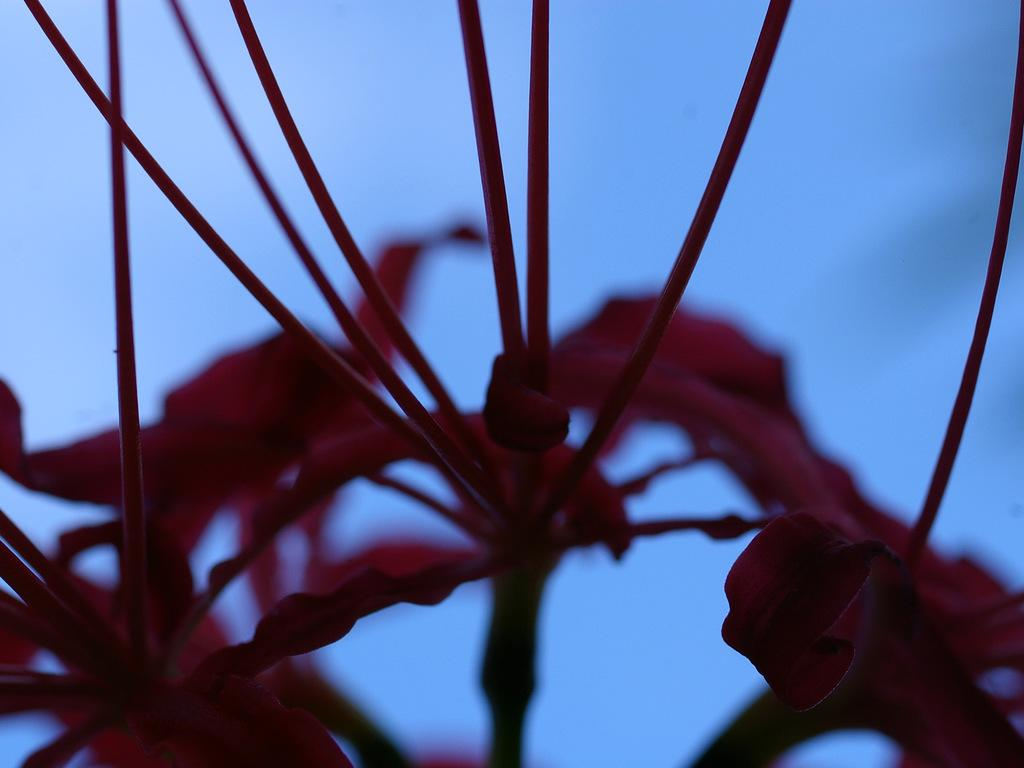What is the main subject of the image? There is a flower in the image. What can be seen in the background of the image? The sky is visible in the background of the image. What type of disease is affecting the flower in the image? There is no indication of any disease affecting the flower in the image. Is there any coal visible in the image? There is no coal present in the image. 